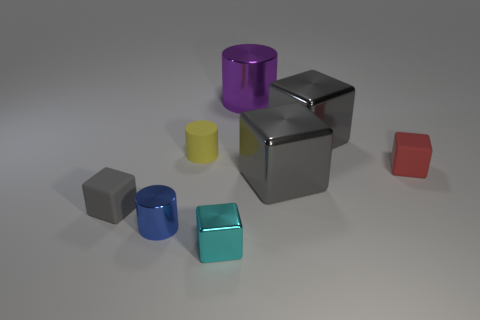Does the cyan object have the same material as the large gray block in front of the small red rubber object?
Your answer should be very brief. Yes. Is there anything else that has the same shape as the red rubber object?
Offer a terse response. Yes. Is the material of the tiny yellow cylinder the same as the tiny cyan object?
Provide a short and direct response. No. Are there any shiny cylinders that are left of the tiny shiny object in front of the small blue metal object?
Make the answer very short. Yes. How many metal cubes are both behind the yellow rubber cylinder and in front of the blue cylinder?
Your response must be concise. 0. There is a matte thing that is on the left side of the blue shiny cylinder; what shape is it?
Offer a terse response. Cube. How many cyan shiny blocks are the same size as the yellow cylinder?
Keep it short and to the point. 1. There is a metallic object that is in front of the tiny blue shiny thing; is it the same color as the rubber cylinder?
Make the answer very short. No. There is a cylinder that is both left of the large shiny cylinder and on the right side of the small metallic cylinder; what is its material?
Your answer should be compact. Rubber. Is the number of small red rubber objects greater than the number of big metal blocks?
Make the answer very short. No. 